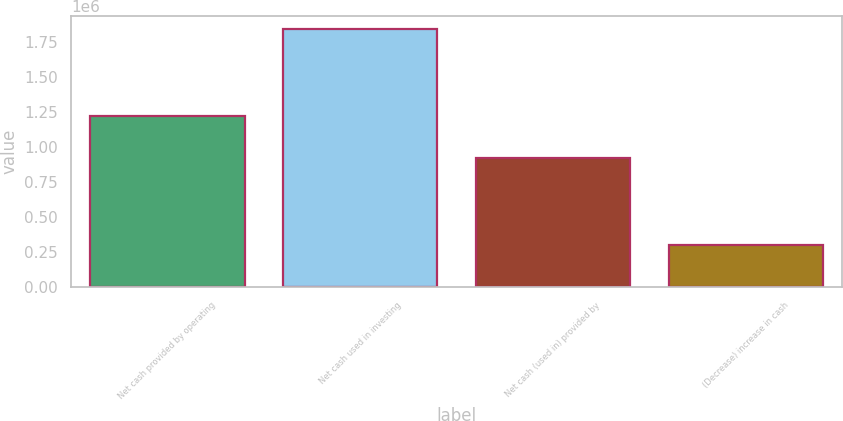Convert chart to OTSL. <chart><loc_0><loc_0><loc_500><loc_500><bar_chart><fcel>Net cash provided by operating<fcel>Net cash used in investing<fcel>Net cash (used in) provided by<fcel>(Decrease) increase in cash<nl><fcel>1.22426e+06<fcel>1.84539e+06<fcel>921278<fcel>300149<nl></chart> 